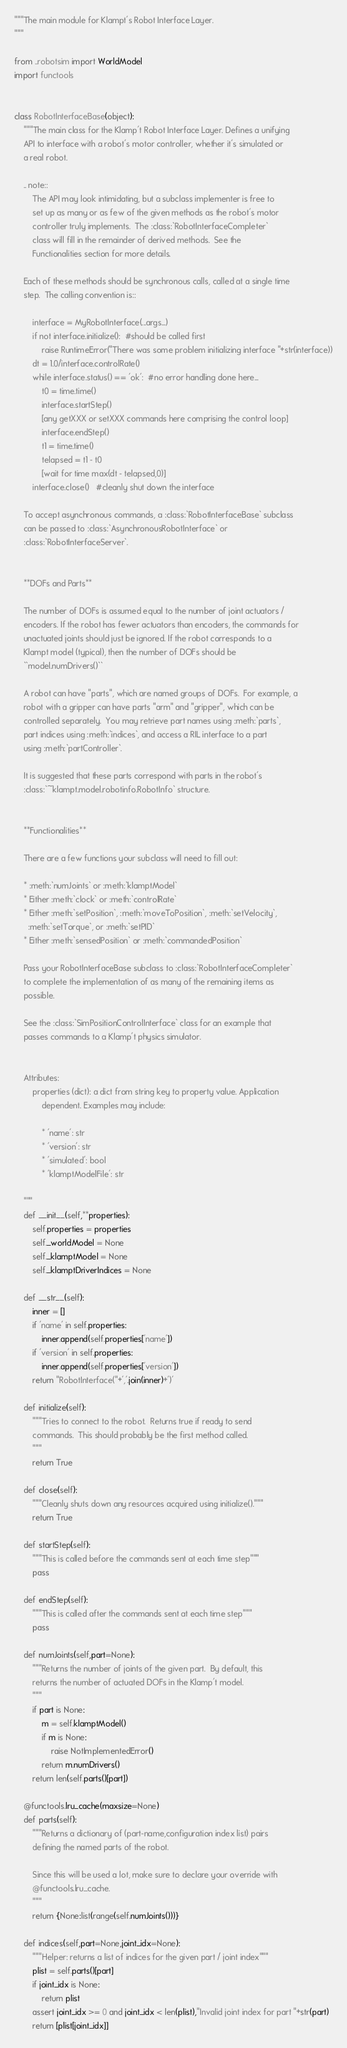Convert code to text. <code><loc_0><loc_0><loc_500><loc_500><_Python_>"""The main module for Klampt's Robot Interface Layer.
"""

from ..robotsim import WorldModel
import functools


class RobotInterfaceBase(object):
    """The main class for the Klamp't Robot Interface Layer. Defines a unifying
    API to interface with a robot's motor controller, whether it's simulated or
    a real robot. 

    .. note::
        The API may look intimidating, but a subclass implementer is free to
        set up as many or as few of the given methods as the robot's motor
        controller truly implements.  The :class:`RobotInterfaceCompleter` 
        class will fill in the remainder of derived methods.  See the
        Functionalities section for more details.
    
    Each of these methods should be synchronous calls, called at a single time
    step.  The calling convention is::

        interface = MyRobotInterface(...args...)
        if not interface.initialize():  #should be called first
            raise RuntimeError("There was some problem initializing interface "+str(interface))
        dt = 1.0/interface.controlRate()
        while interface.status() == 'ok':  #no error handling done here...
            t0 = time.time()
            interface.startStep()
            [any getXXX or setXXX commands here comprising the control loop]
            interface.endStep()
            t1 = time.time()
            telapsed = t1 - t0
            [wait for time max(dt - telapsed,0)]
        interface.close()   #cleanly shut down the interface

    To accept asynchronous commands, a :class:`RobotInterfaceBase` subclass
    can be passed to :class:`AsynchronousRobotInterface` or
    :class:`RobotInterfaceServer`.


    **DOFs and Parts**

    The number of DOFs is assumed equal to the number of joint actuators / 
    encoders. If the robot has fewer actuators than encoders, the commands for 
    unactuated joints should just be ignored. If the robot corresponds to a 
    Klampt model (typical), then the number of DOFs should be
    ``model.numDrivers()``

    A robot can have "parts", which are named groups of DOFs.  For example, a
    robot with a gripper can have parts "arm" and "gripper", which can be 
    controlled separately.  You may retrieve part names using :meth:`parts`, 
    part indices using :meth:`indices`, and access a RIL interface to a part
    using :meth:`partController`. 

    It is suggested that these parts correspond with parts in the robot's 
    :class:`~klampt.model.robotinfo.RobotInfo` structure.


    **Functionalities**

    There are a few functions your subclass will need to fill out:

    * :meth:`numJoints` or :meth:`klamptModel`
    * Either :meth:`clock` or :meth:`controlRate`
    * Either :meth:`setPosition`, :meth:`moveToPosition`, :meth:`setVelocity`, 
      :meth:`setTorque`, or :meth:`setPID`
    * Either :meth:`sensedPosition` or :meth:`commandedPosition`

    Pass your RobotInterfaceBase subclass to :class:`RobotInterfaceCompleter`
    to complete the implementation of as many of the remaining items as
    possible.

    See the :class:`SimPositionControlInterface` class for an example that
    passes commands to a Klamp't physics simulator.


    Attributes:
        properties (dict): a dict from string key to property value. Application
            dependent. Examples may include:

            * 'name': str
            * 'version': str
            * 'simulated': bool
            * 'klamptModelFile': str

    """
    def __init__(self,**properties):
        self.properties = properties
        self._worldModel = None
        self._klamptModel = None
        self._klamptDriverIndices = None

    def __str__(self):
        inner = []
        if 'name' in self.properties:
            inner.append(self.properties['name'])
        if 'version' in self.properties:
            inner.append(self.properties['version'])
        return "RobotInterface("+','.join(inner)+')'

    def initialize(self):
        """Tries to connect to the robot.  Returns true if ready to send
        commands.  This should probably be the first method called.
        """
        return True

    def close(self):
        """Cleanly shuts down any resources acquired using initialize()."""
        return True

    def startStep(self):
        """This is called before the commands sent at each time step"""
        pass

    def endStep(self):
        """This is called after the commands sent at each time step"""
        pass

    def numJoints(self,part=None):
        """Returns the number of joints of the given part.  By default, this
        returns the number of actuated DOFs in the Klamp't model. 
        """
        if part is None:
            m = self.klamptModel()
            if m is None:
                raise NotImplementedError()
            return m.numDrivers()
        return len(self.parts()[part])

    @functools.lru_cache(maxsize=None)
    def parts(self):
        """Returns a dictionary of (part-name,configuration index list) pairs
        defining the named parts of the robot.

        Since this will be used a lot, make sure to declare your override with
        @functools.lru_cache.
        """
        return {None:list(range(self.numJoints()))}

    def indices(self,part=None,joint_idx=None):
        """Helper: returns a list of indices for the given part / joint index"""
        plist = self.parts()[part]
        if joint_idx is None:
            return plist
        assert joint_idx >= 0 and joint_idx < len(plist),"Invalid joint index for part "+str(part)
        return [plist[joint_idx]]
</code> 